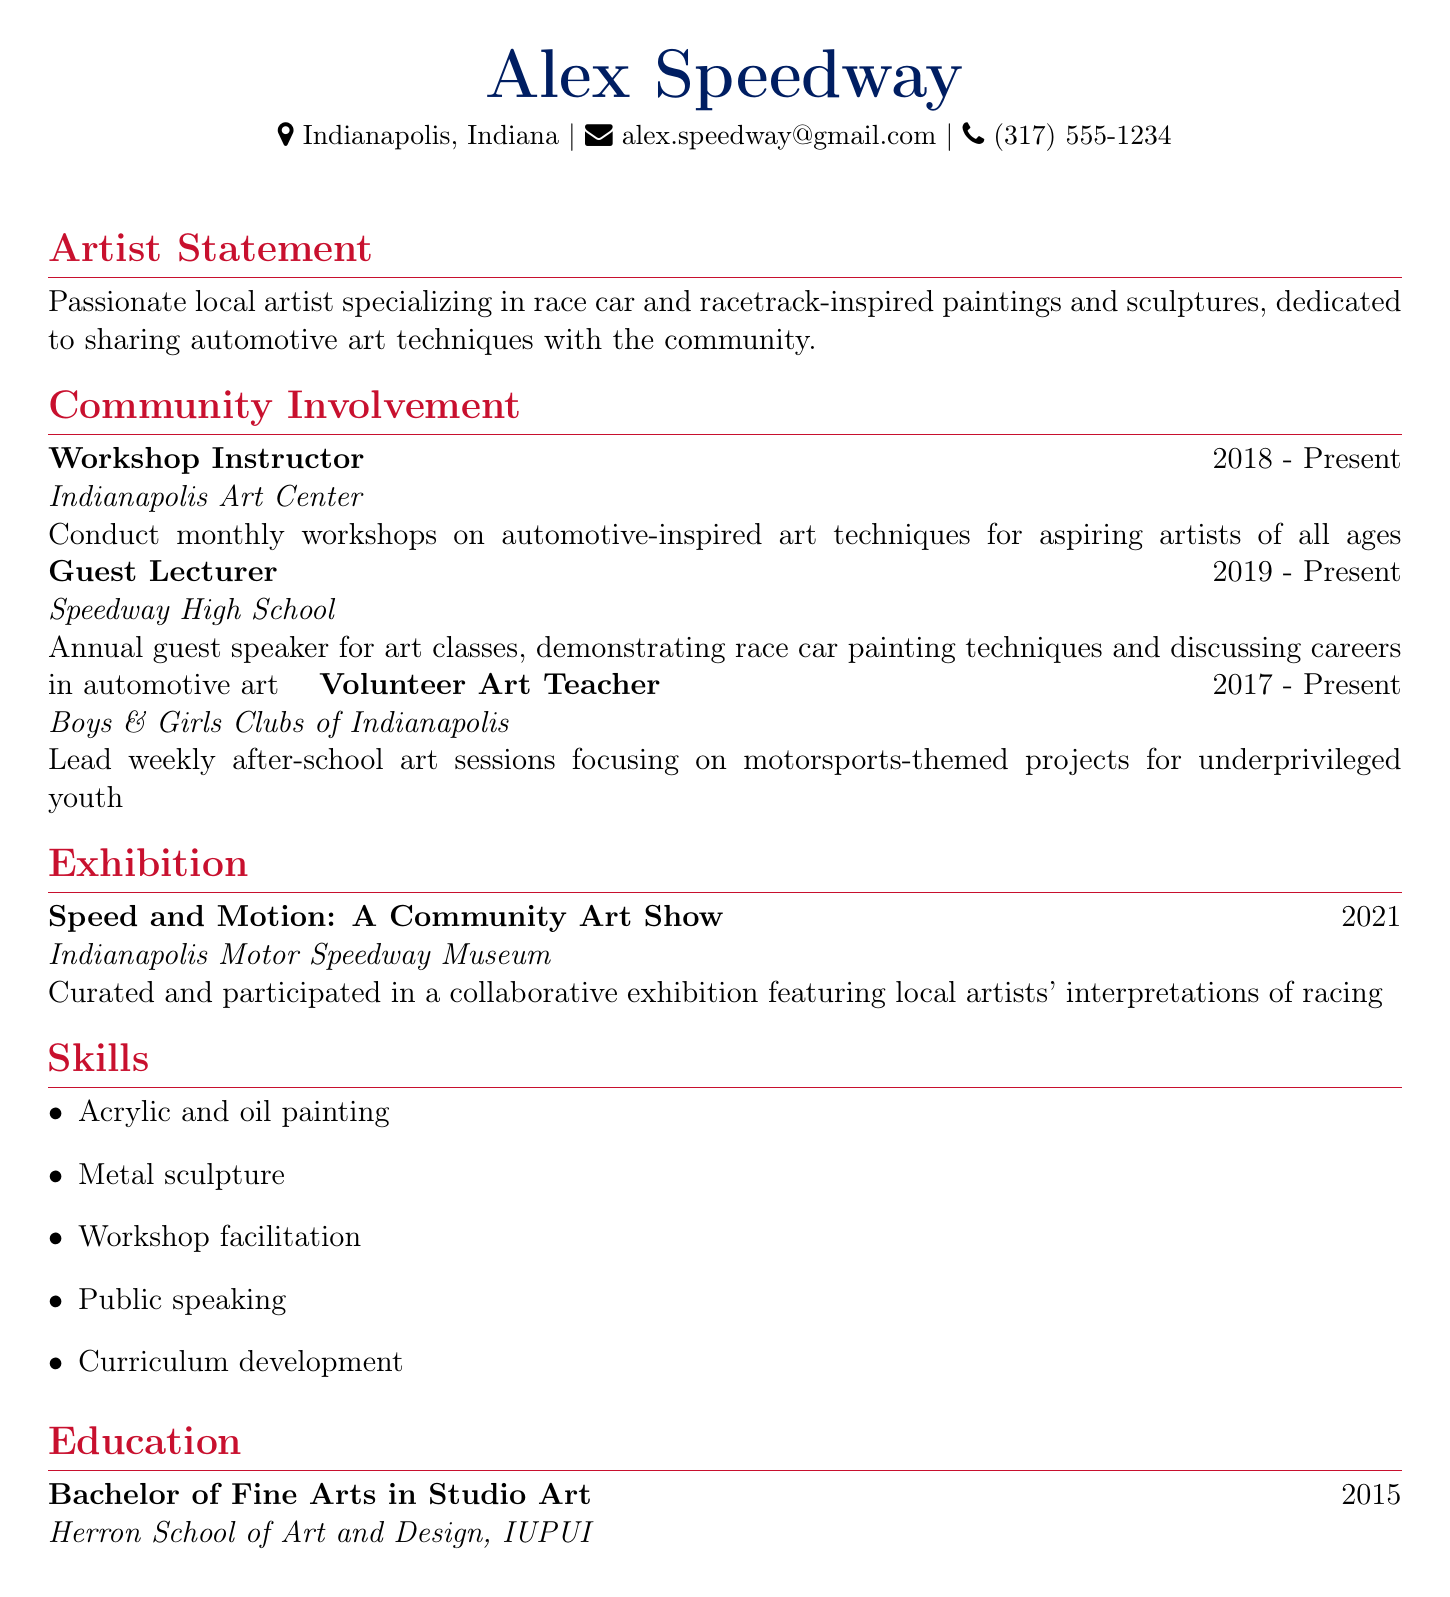what is the name of the artist? The document states the artist's name at the beginning, which is Alex Speedway.
Answer: Alex Speedway where does the artist live? The location is provided directly under the name in the document.
Answer: Indianapolis, Indiana what is the email address of the artist? The email address is listed in the contact information section.
Answer: alex.speedway@gmail.com how many years has the artist been conducting workshops? The duration of the workshops is 2018 to present, which indicates the number of years of experience.
Answer: 5 years which organization does the artist teach art workshops? The organization is listed in the community involvement section.
Answer: Indianapolis Art Center what is the title of the exhibition mentioned in the document? The title of the exhibition is highlighted under the exhibition section.
Answer: Speed and Motion: A Community Art Show what subjects does the artist focus on in workshops? The description of the workshops in the community involvement section provides this information.
Answer: Automotive-inspired art techniques how many organizations are mentioned in the community involvement section? The community involvement section lists three distinct organizations where the artist is involved.
Answer: 3 organizations what degree did the artist earn? The education section shows the degree conferred upon the artist from the institution stated.
Answer: Bachelor of Fine Arts what type of teaching role does the artist have at the Boys & Girls Clubs of Indianapolis? The document specifies the artist's role in the community involvement section.
Answer: Volunteer Art Teacher 